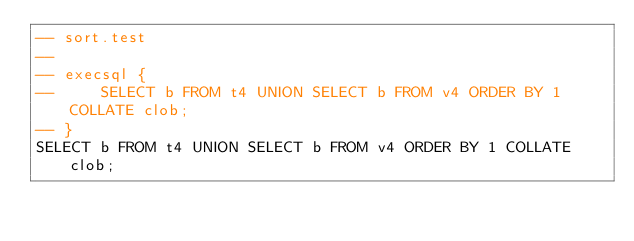Convert code to text. <code><loc_0><loc_0><loc_500><loc_500><_SQL_>-- sort.test
-- 
-- execsql {
--     SELECT b FROM t4 UNION SELECT b FROM v4 ORDER BY 1 COLLATE clob;
-- }
SELECT b FROM t4 UNION SELECT b FROM v4 ORDER BY 1 COLLATE clob;

</code> 